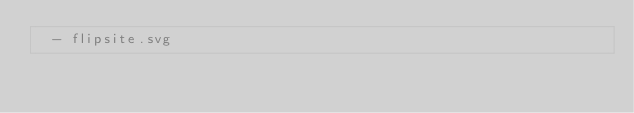Convert code to text. <code><loc_0><loc_0><loc_500><loc_500><_YAML_>  - flipsite.svg</code> 